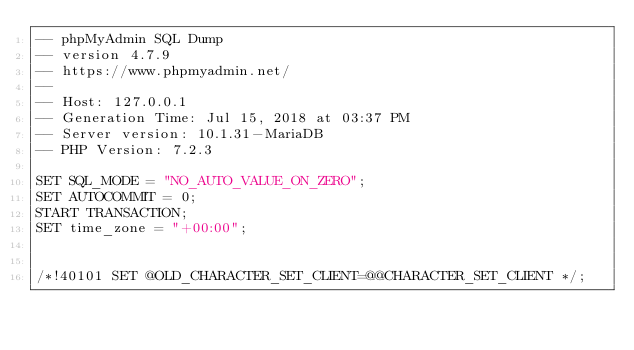<code> <loc_0><loc_0><loc_500><loc_500><_SQL_>-- phpMyAdmin SQL Dump
-- version 4.7.9
-- https://www.phpmyadmin.net/
--
-- Host: 127.0.0.1
-- Generation Time: Jul 15, 2018 at 03:37 PM
-- Server version: 10.1.31-MariaDB
-- PHP Version: 7.2.3

SET SQL_MODE = "NO_AUTO_VALUE_ON_ZERO";
SET AUTOCOMMIT = 0;
START TRANSACTION;
SET time_zone = "+00:00";


/*!40101 SET @OLD_CHARACTER_SET_CLIENT=@@CHARACTER_SET_CLIENT */;</code> 